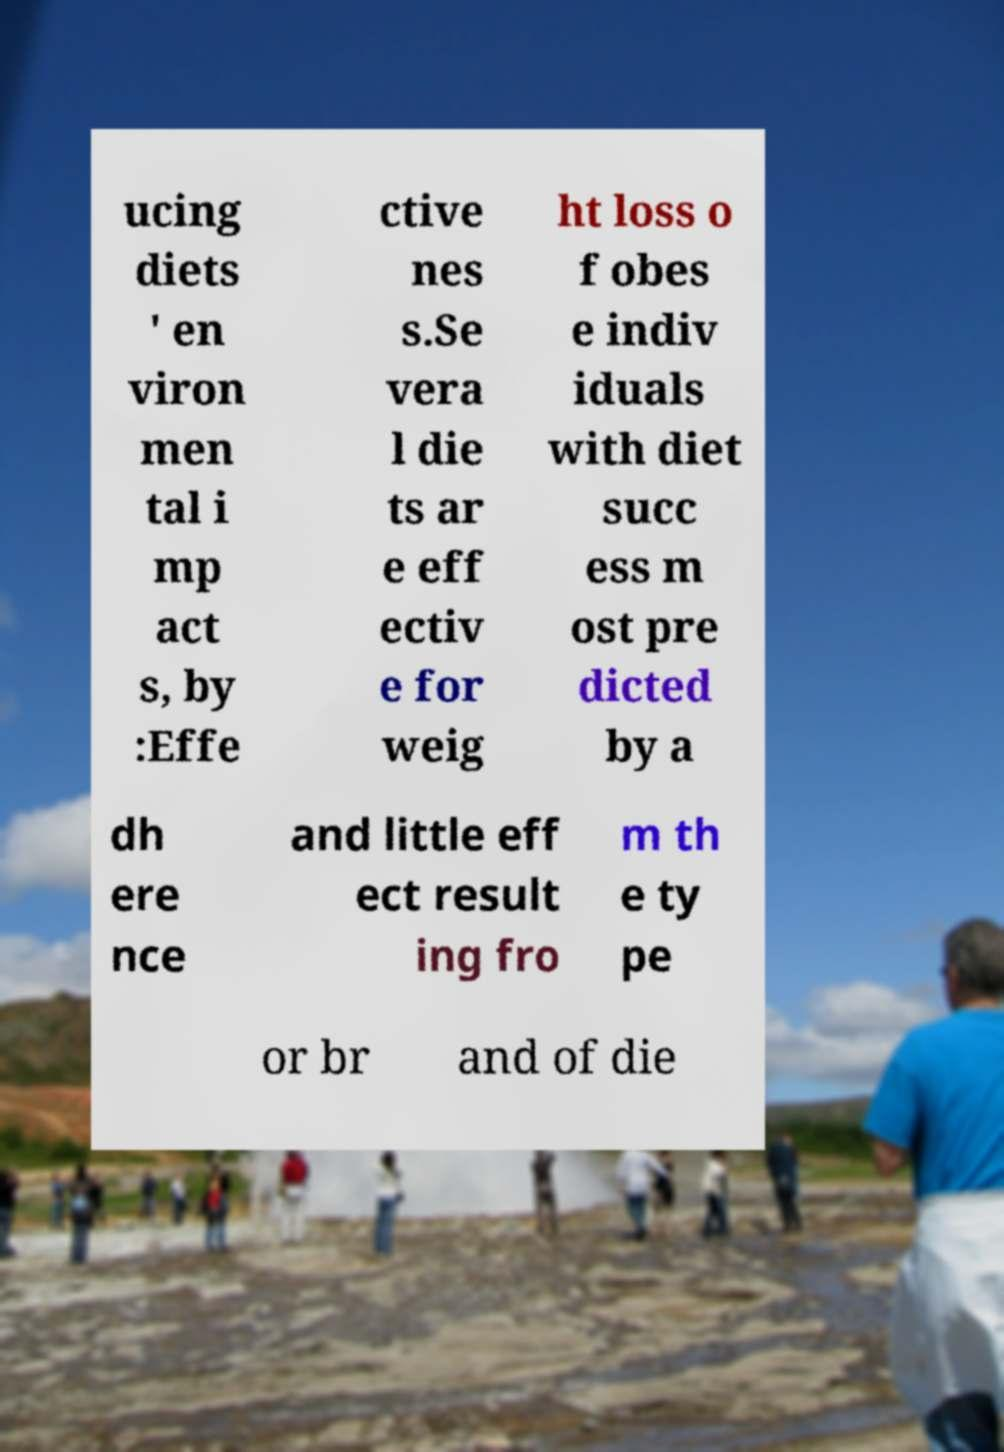There's text embedded in this image that I need extracted. Can you transcribe it verbatim? ucing diets ' en viron men tal i mp act s, by :Effe ctive nes s.Se vera l die ts ar e eff ectiv e for weig ht loss o f obes e indiv iduals with diet succ ess m ost pre dicted by a dh ere nce and little eff ect result ing fro m th e ty pe or br and of die 